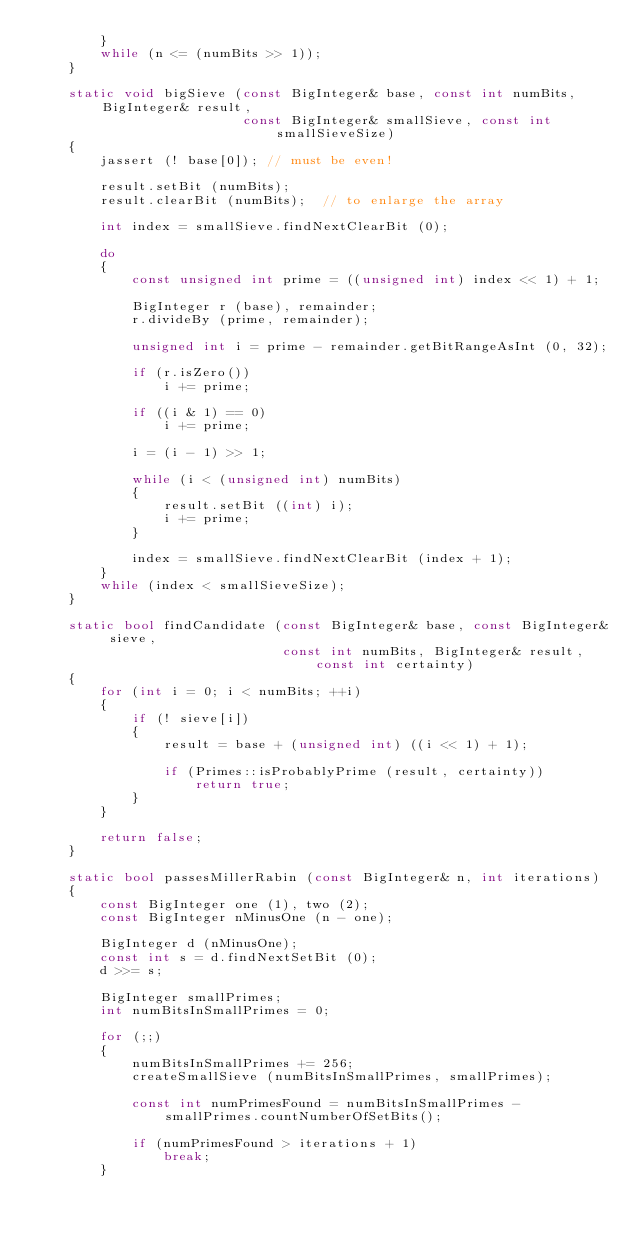Convert code to text. <code><loc_0><loc_0><loc_500><loc_500><_C++_>        }
        while (n <= (numBits >> 1));
    }

    static void bigSieve (const BigInteger& base, const int numBits, BigInteger& result,
                          const BigInteger& smallSieve, const int smallSieveSize)
    {
        jassert (! base[0]); // must be even!

        result.setBit (numBits);
        result.clearBit (numBits);  // to enlarge the array

        int index = smallSieve.findNextClearBit (0);

        do
        {
            const unsigned int prime = ((unsigned int) index << 1) + 1;

            BigInteger r (base), remainder;
            r.divideBy (prime, remainder);

            unsigned int i = prime - remainder.getBitRangeAsInt (0, 32);

            if (r.isZero())
                i += prime;

            if ((i & 1) == 0)
                i += prime;

            i = (i - 1) >> 1;

            while (i < (unsigned int) numBits)
            {
                result.setBit ((int) i);
                i += prime;
            }

            index = smallSieve.findNextClearBit (index + 1);
        }
        while (index < smallSieveSize);
    }

    static bool findCandidate (const BigInteger& base, const BigInteger& sieve,
                               const int numBits, BigInteger& result, const int certainty)
    {
        for (int i = 0; i < numBits; ++i)
        {
            if (! sieve[i])
            {
                result = base + (unsigned int) ((i << 1) + 1);

                if (Primes::isProbablyPrime (result, certainty))
                    return true;
            }
        }

        return false;
    }

    static bool passesMillerRabin (const BigInteger& n, int iterations)
    {
        const BigInteger one (1), two (2);
        const BigInteger nMinusOne (n - one);

        BigInteger d (nMinusOne);
        const int s = d.findNextSetBit (0);
        d >>= s;

        BigInteger smallPrimes;
        int numBitsInSmallPrimes = 0;

        for (;;)
        {
            numBitsInSmallPrimes += 256;
            createSmallSieve (numBitsInSmallPrimes, smallPrimes);

            const int numPrimesFound = numBitsInSmallPrimes - smallPrimes.countNumberOfSetBits();

            if (numPrimesFound > iterations + 1)
                break;
        }
</code> 